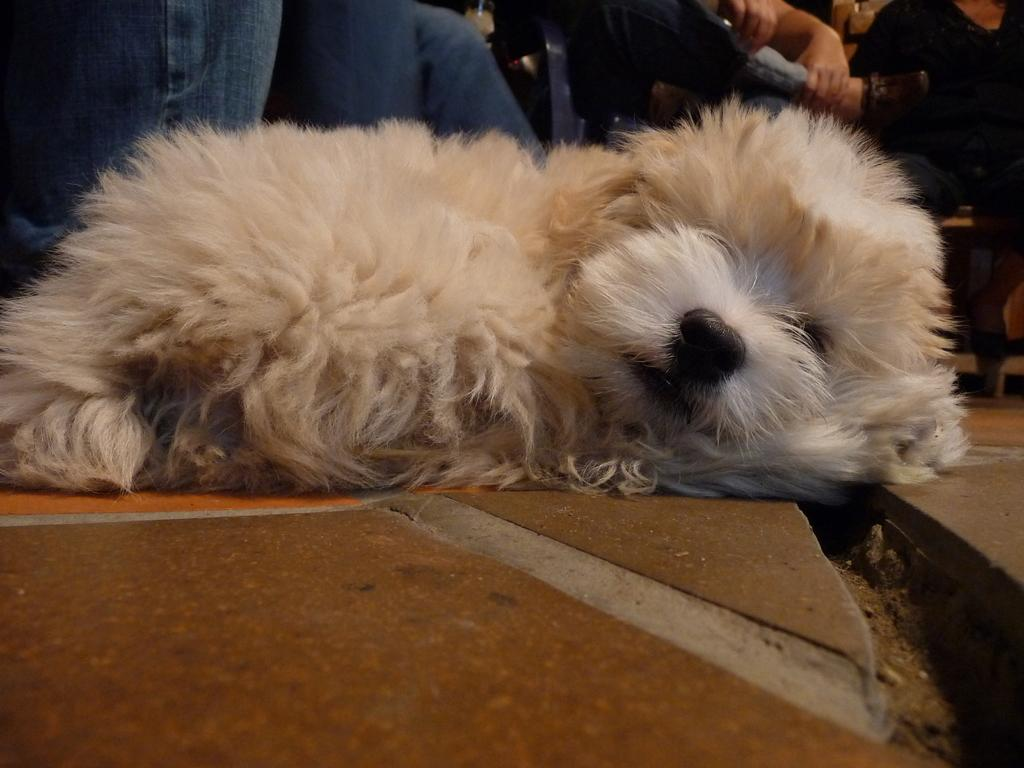What animal is present in the image? There is a dog in the image. What is the dog standing on? The dog is on a brown surface. What colors does the dog have? The dog is white and cream in color. What can be seen in the background of the image? There is a group of people in the background of the image. What colors are the people wearing? The people are wearing blue and black dresses. Are there any dinosaurs visible in the image? No, there are no dinosaurs present in the image. Can you tell me the name of the country where the dog and people are located? The provided facts do not mention any specific country, so it cannot be determined from the image. 